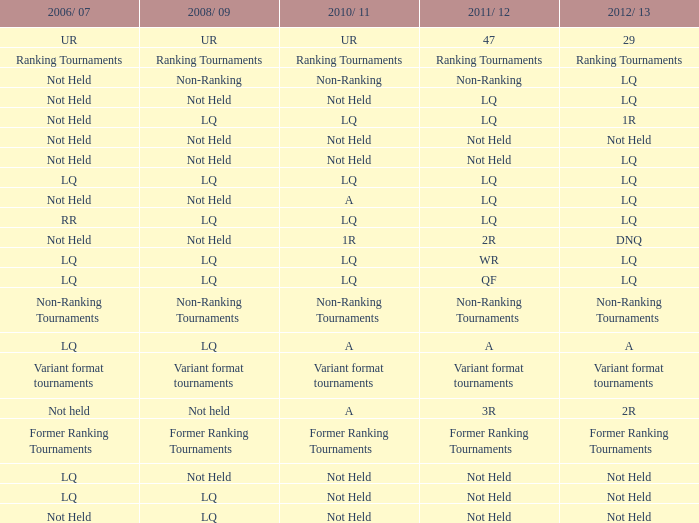What is 2006/07, when 2008/09 is LQ, and when 2010/11 is Not Held? LQ, Not Held. 